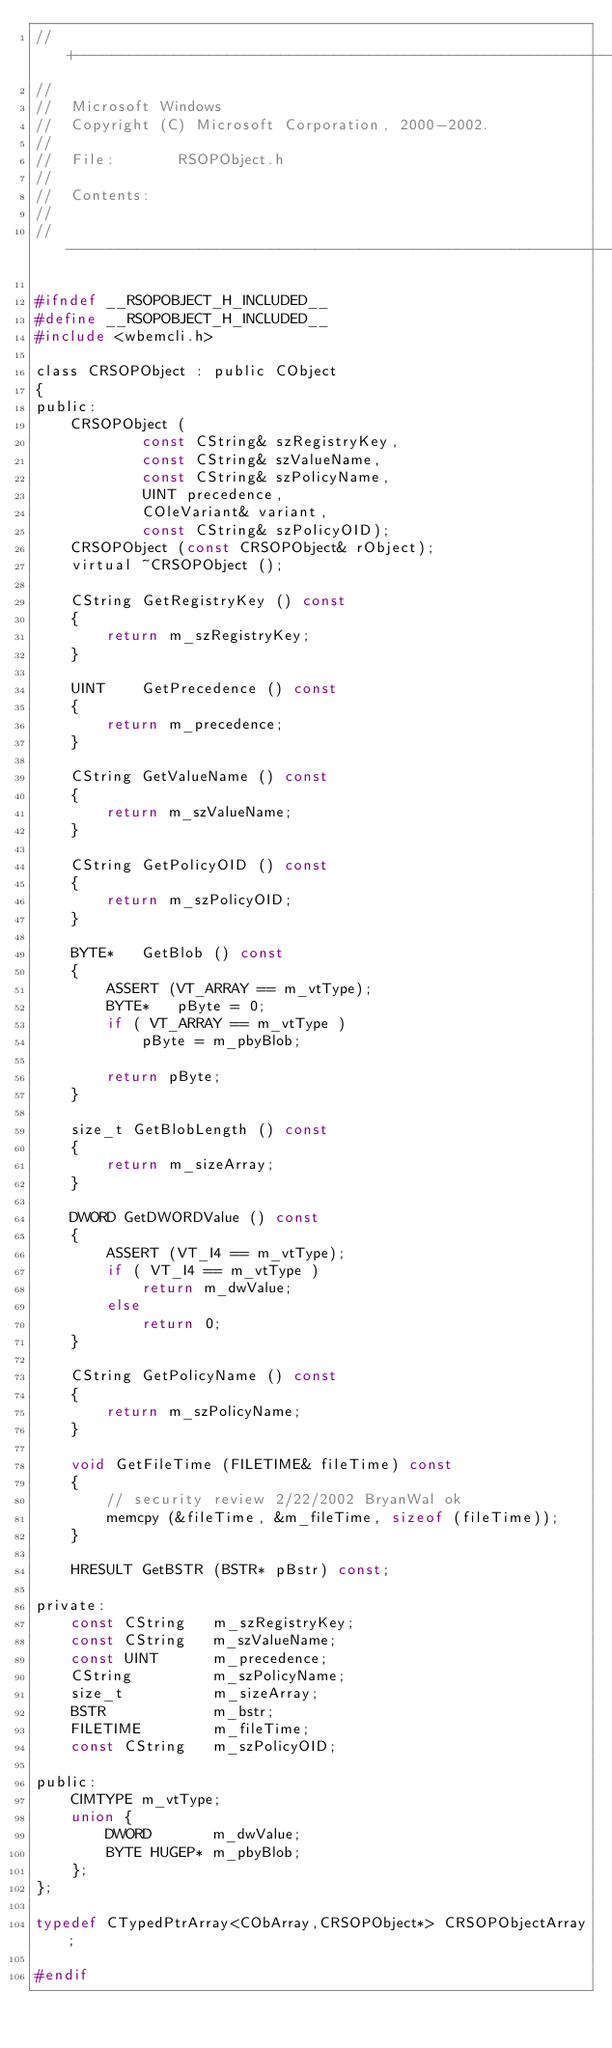Convert code to text. <code><loc_0><loc_0><loc_500><loc_500><_C_>//+---------------------------------------------------------------------------
//
//  Microsoft Windows
//  Copyright (C) Microsoft Corporation, 2000-2002.
//
//  File:       RSOPObject.h
//
//  Contents:
//
//----------------------------------------------------------------------------

#ifndef __RSOPOBJECT_H_INCLUDED__
#define __RSOPOBJECT_H_INCLUDED__
#include <wbemcli.h>

class CRSOPObject : public CObject 
{
public:
    CRSOPObject (
            const CString& szRegistryKey, 
            const CString& szValueName, 
            const CString& szPolicyName,
            UINT precedence, 
            COleVariant& variant,
            const CString& szPolicyOID);
    CRSOPObject (const CRSOPObject& rObject);
    virtual ~CRSOPObject ();

    CString GetRegistryKey () const
    {
        return m_szRegistryKey;
    }

    UINT    GetPrecedence () const
    {
        return m_precedence;
    }

    CString GetValueName () const
    {
        return m_szValueName;
    }

    CString GetPolicyOID () const
    {
        return m_szPolicyOID;
    }

    BYTE*   GetBlob () const
    {
        ASSERT (VT_ARRAY == m_vtType);
        BYTE*   pByte = 0;
        if ( VT_ARRAY == m_vtType )
            pByte = m_pbyBlob;

        return pByte;
    }

    size_t GetBlobLength () const
    {
        return m_sizeArray;
    }

    DWORD GetDWORDValue () const
    {
        ASSERT (VT_I4 == m_vtType);
        if ( VT_I4 == m_vtType )
            return m_dwValue;
        else
            return 0;
    }

    CString GetPolicyName () const
    {
        return m_szPolicyName;
    }

    void GetFileTime (FILETIME& fileTime) const
    {
        // security review 2/22/2002 BryanWal ok
        memcpy (&fileTime, &m_fileTime, sizeof (fileTime));
    }

    HRESULT GetBSTR (BSTR* pBstr) const;

private:
    const CString   m_szRegistryKey;
    const CString   m_szValueName;
    const UINT      m_precedence;
    CString         m_szPolicyName;
    size_t          m_sizeArray;
    BSTR            m_bstr;
    FILETIME        m_fileTime;
    const CString   m_szPolicyOID;

public:
    CIMTYPE m_vtType;
    union {
        DWORD       m_dwValue;
        BYTE HUGEP* m_pbyBlob;
    }; 
};

typedef CTypedPtrArray<CObArray,CRSOPObject*> CRSOPObjectArray;

#endif</code> 